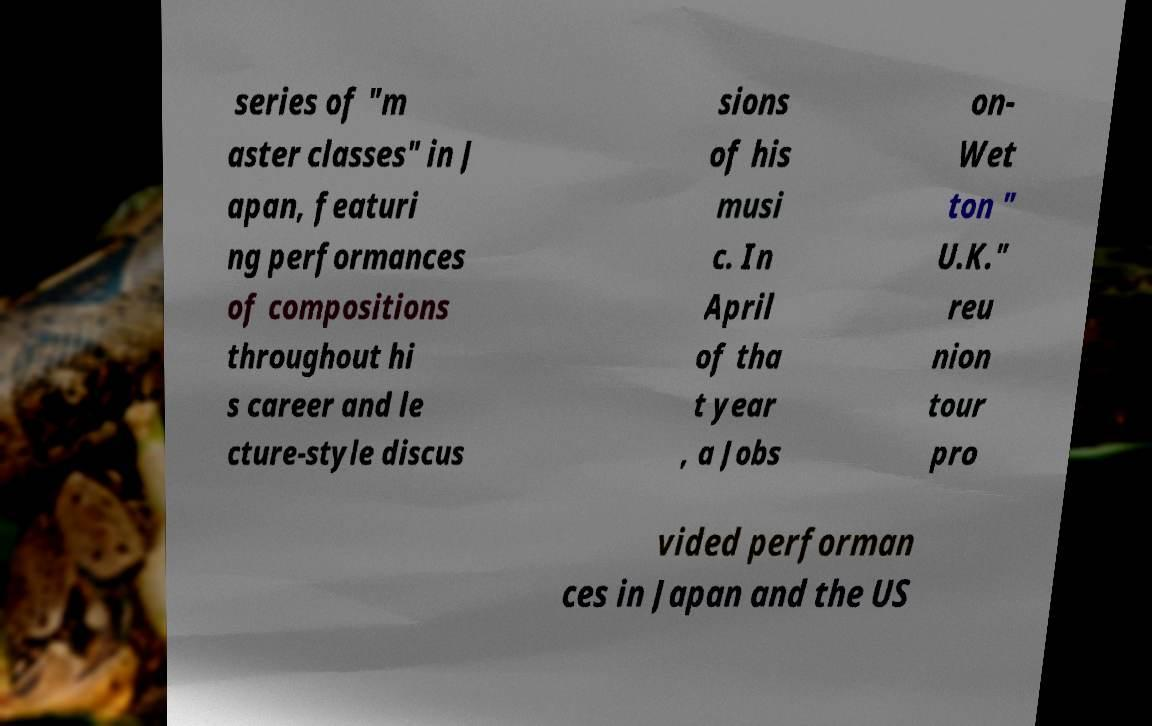Could you assist in decoding the text presented in this image and type it out clearly? series of "m aster classes" in J apan, featuri ng performances of compositions throughout hi s career and le cture-style discus sions of his musi c. In April of tha t year , a Jobs on- Wet ton " U.K." reu nion tour pro vided performan ces in Japan and the US 